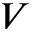Convert formula to latex. <formula><loc_0><loc_0><loc_500><loc_500>V</formula> 